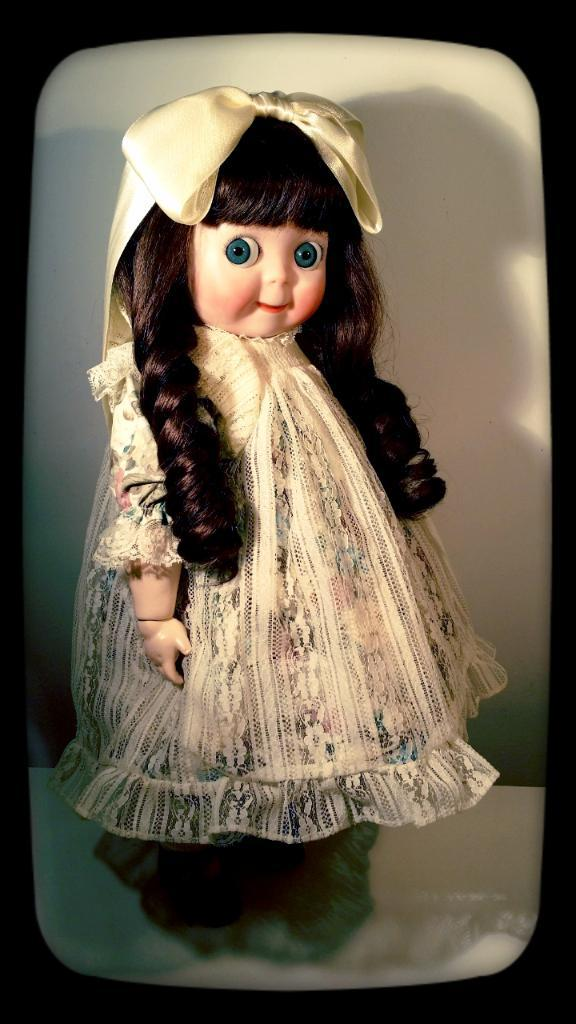What is the main subject of the image? There is a doll in the image. What color is used for the borders of the image? The borders of the image are black in color. What type of substance is being used to build the wall in the image? There is no wall present in the image, so it is not possible to determine what substance might be used to build it. 